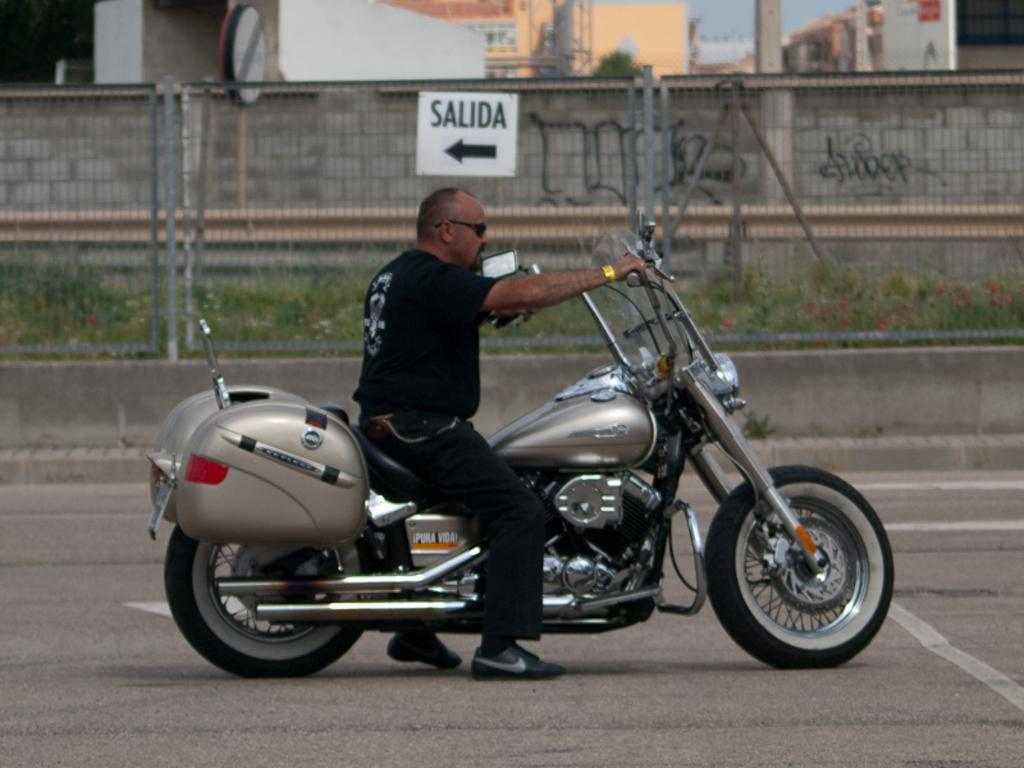What is the man in the image doing? There is a man sitting on a motorbike in the image. What can be seen in the background of the image? There are buildings in the distance. What is visible between the motorbike and the buildings? There is a fence visible in the image. What type of vegetation is present in the image? There are plants with flowers in the image. What type of weather can be seen in the image? The provided facts do not mention any weather conditions, so it cannot be determined from the image. What type of apparel is the man wearing in the image? The provided facts do not mention any specific apparel that the man is wearing in the image. What type of approval is required for the man to ride the motorbike in the image? The provided facts do not mention any requirements for approval to ride the motorbike in the image. 